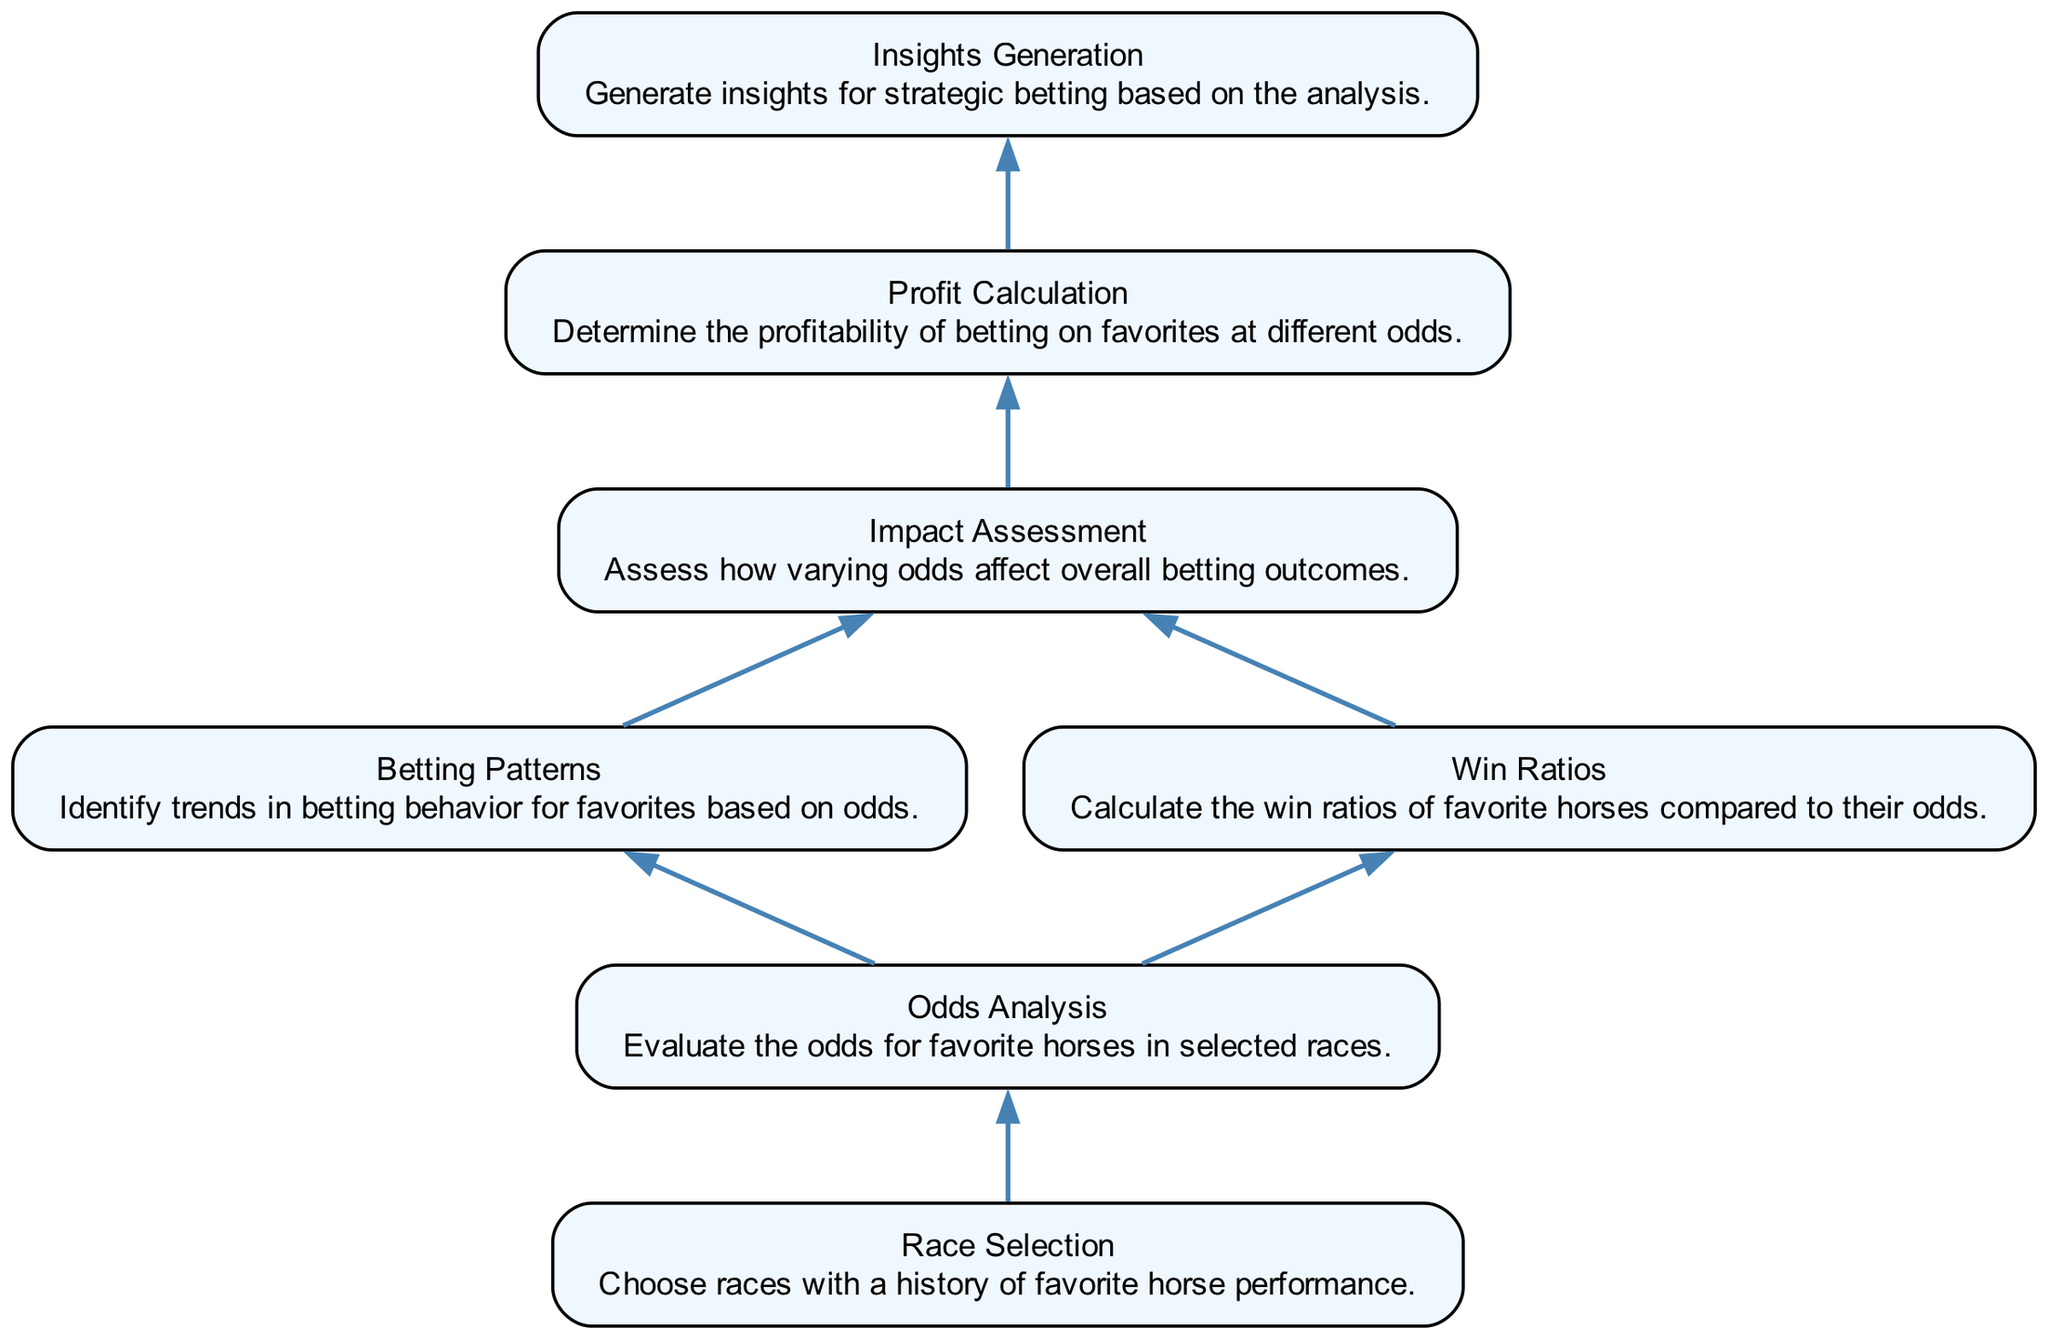What is the first step in the flowchart? The first step is "Race Selection," which is the starting point of the flowchart indicating that races should be chosen based on the historical performance of favorite horses.
Answer: Race Selection How many nodes are in the diagram? By counting each distinct element in the flowchart, we identify seven nodes: Race Selection, Odds Analysis, Betting Patterns, Win Ratios, Impact Assessment, Profit Calculation, and Insights Generation.
Answer: Seven What node directly follows the "Odds Analysis" node? The "Betting Patterns" and "Win Ratios" nodes both directly follow "Odds Analysis," as these are their immediate successors according to the directed edges in the flowchart.
Answer: Betting Patterns, Win Ratios Which step comes before "Profit Calculation"? "Impact Assessment" is the step that comes directly before "Profit Calculation," which can be seen by tracing the flow from "Impact Assessment" to "Profit Calculation."
Answer: Impact Assessment What is the final result of the flowchart process? The final result of the process is "Insights Generation," which represents the generation of strategic betting insights based on earlier analyses.
Answer: Insights Generation Which two nodes feed into the "Impact Assessment"? The nodes "Betting Patterns" and "Win Ratios" both feed into "Impact Assessment," which means both of these analyses contribute information to assess the impact on betting outcomes.
Answer: Betting Patterns, Win Ratios What is the relationship between "Odds Analysis" and "Win Ratios"? "Odds Analysis" influences "Win Ratios" because the evaluation of odds is a prerequisite to calculating the win ratios of favorite horses.
Answer: Influence Which node has the most connections in the flowchart? The "Impact Assessment" node has the most connections, receiving information from both "Betting Patterns" and "Win Ratios," leading into it before further progression to "Profit Calculation."
Answer: Impact Assessment 